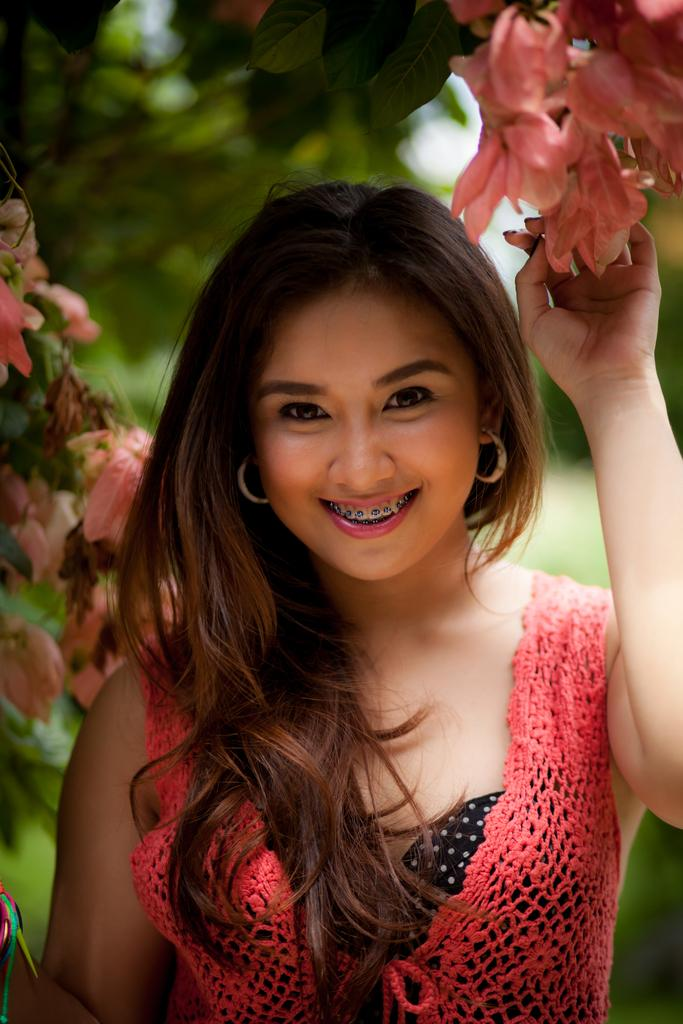Who is the main subject in the picture? There is a girl in the picture. What is the girl doing in the image? The girl is standing and holding flowers. What is the girl's facial expression in the image? The girl is smiling in the image. What direction is the girl looking in the image? The girl is looking straight in the image. Can you describe the background of the image? The back side of the image is blurred. What type of sheep can be seen teaching the girl in the image? There are no sheep or any teaching activity present in the image. 